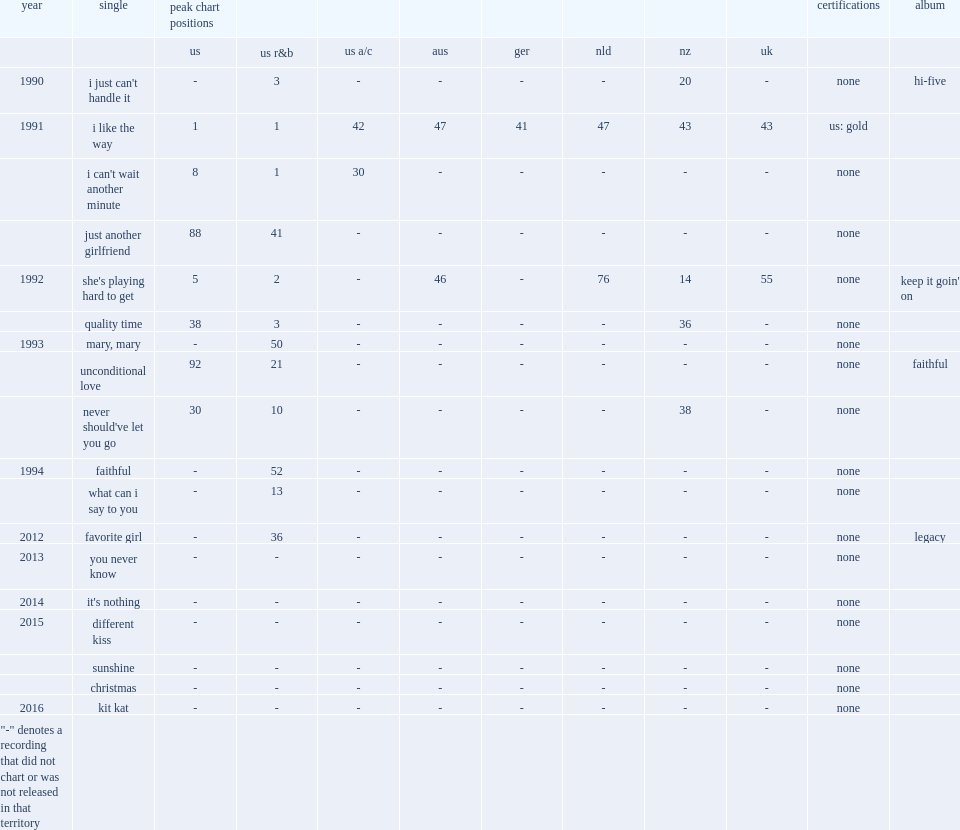What was the peak chart position on the us r&b of unconditional love? 21.0. 